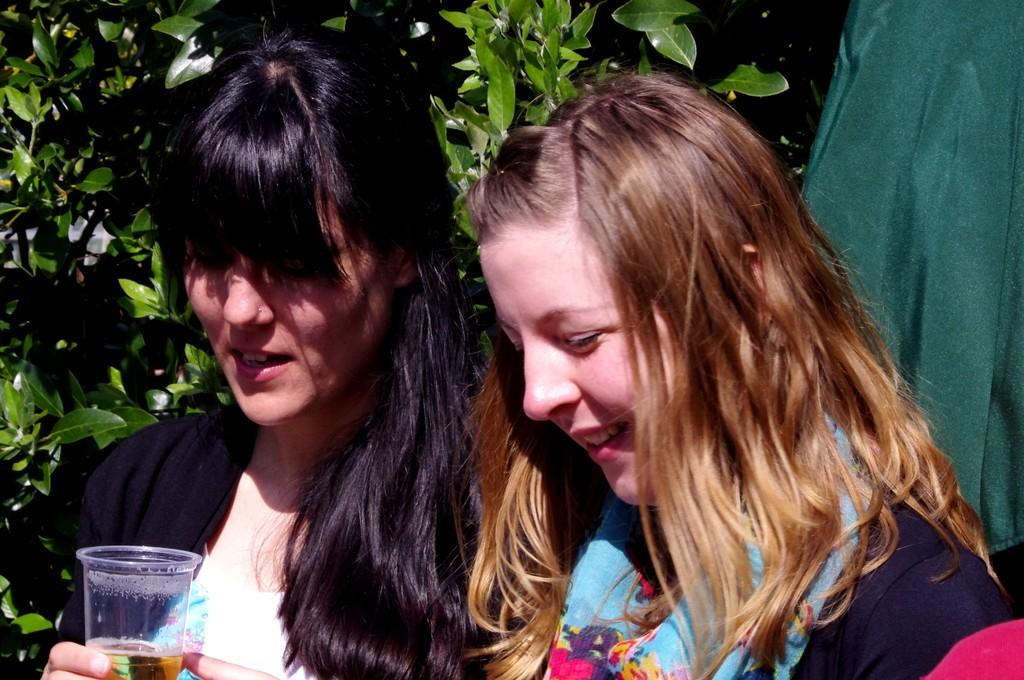How many women are present in the image? There are two women in the image. What is one of the women holding? One of the women is holding a glass. What is the other woman doing in the image? The other woman is smiling. What can be seen in the background of the image? There are trees in the background of the image. What type of frame is surrounding the women in the image? There is no frame surrounding the women in the image; it is a photograph or digital image without a frame. How many cattle can be seen in the image? There are no cattle present in the image. 